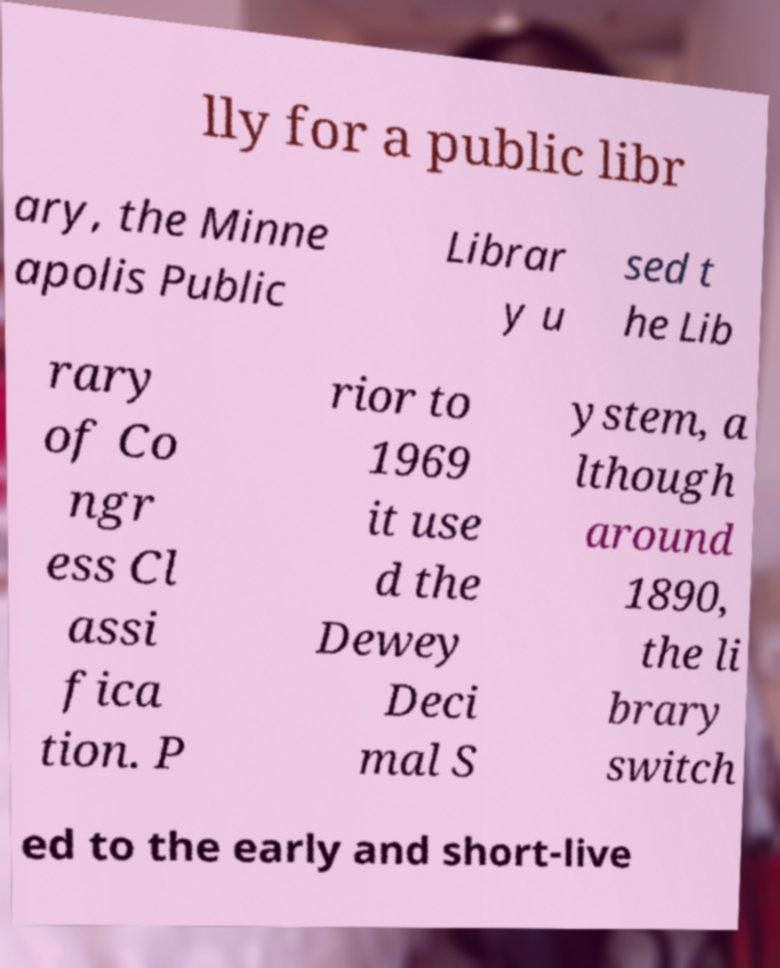Could you extract and type out the text from this image? lly for a public libr ary, the Minne apolis Public Librar y u sed t he Lib rary of Co ngr ess Cl assi fica tion. P rior to 1969 it use d the Dewey Deci mal S ystem, a lthough around 1890, the li brary switch ed to the early and short-live 